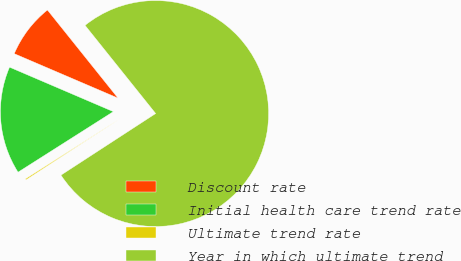Convert chart. <chart><loc_0><loc_0><loc_500><loc_500><pie_chart><fcel>Discount rate<fcel>Initial health care trend rate<fcel>Ultimate trend rate<fcel>Year in which ultimate trend<nl><fcel>7.81%<fcel>15.45%<fcel>0.17%<fcel>76.57%<nl></chart> 